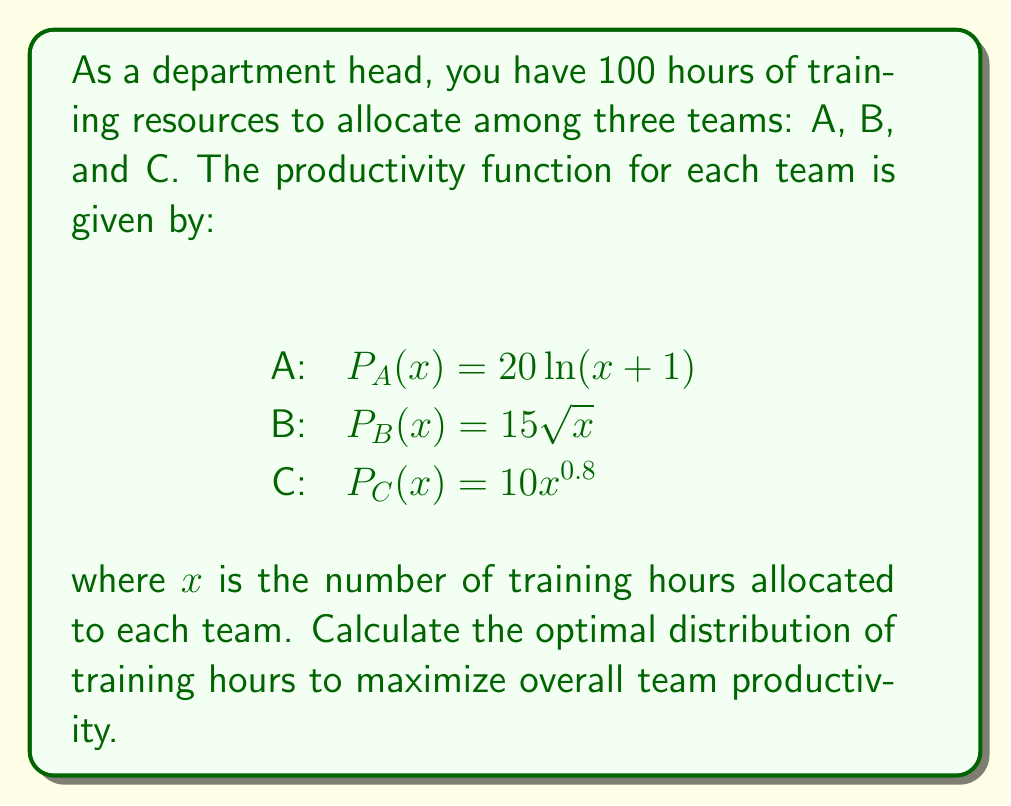Can you answer this question? To maximize overall team productivity, we need to find the optimal allocation of training hours that equates the marginal productivity of each team. We'll use the method of Lagrange multipliers:

1) Let $x$, $y$, and $z$ be the hours allocated to teams A, B, and C respectively.

2) Our objective function is:
   $f(x,y,z) = 20\ln(x+1) + 15\sqrt{y} + 10z^{0.8}$

3) The constraint is:
   $g(x,y,z) = x + y + z - 100 = 0$

4) We form the Lagrangian:
   $L(x,y,z,\lambda) = 20\ln(x+1) + 15\sqrt{y} + 10z^{0.8} - \lambda(x + y + z - 100)$

5) We set the partial derivatives equal to zero:

   $\frac{\partial L}{\partial x} = \frac{20}{x+1} - \lambda = 0$
   $\frac{\partial L}{\partial y} = \frac{15}{2\sqrt{y}} - \lambda = 0$
   $\frac{\partial L}{\partial z} = 8z^{-0.2} - \lambda = 0$
   $\frac{\partial L}{\partial \lambda} = x + y + z - 100 = 0$

6) From these equations, we can derive:

   $\frac{20}{x+1} = \frac{15}{2\sqrt{y}} = 8z^{-0.2}$

7) Solving these equations simultaneously with the constraint:

   $x \approx 39.2$
   $y \approx 30.6$
   $z \approx 30.2$

8) Rounding to the nearest whole number (as we're dealing with hours):

   $x = 39$
   $y = 31$
   $z = 30$

This distribution maximizes overall team productivity.
Answer: Team A: 39 hours, Team B: 31 hours, Team C: 30 hours 